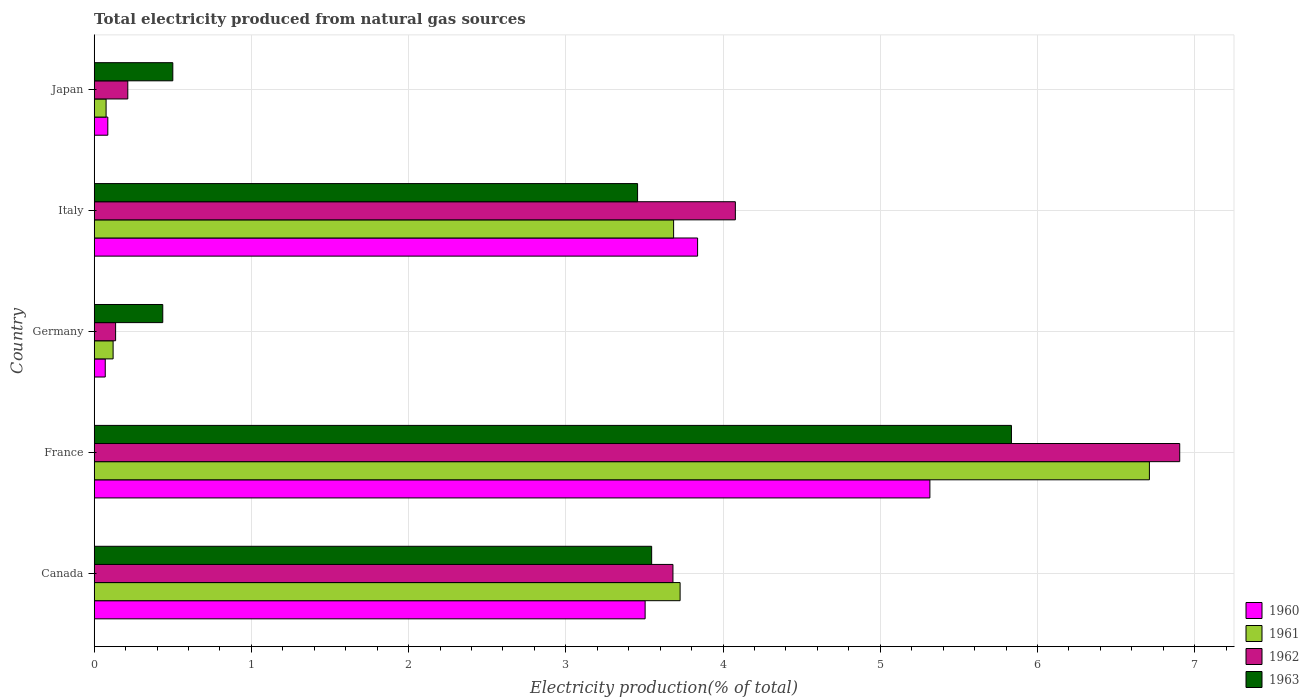Are the number of bars per tick equal to the number of legend labels?
Provide a succinct answer. Yes. How many bars are there on the 5th tick from the top?
Offer a very short reply. 4. How many bars are there on the 3rd tick from the bottom?
Give a very brief answer. 4. What is the label of the 1st group of bars from the top?
Provide a short and direct response. Japan. In how many cases, is the number of bars for a given country not equal to the number of legend labels?
Your answer should be very brief. 0. What is the total electricity produced in 1963 in Germany?
Give a very brief answer. 0.44. Across all countries, what is the maximum total electricity produced in 1961?
Ensure brevity in your answer.  6.71. Across all countries, what is the minimum total electricity produced in 1961?
Make the answer very short. 0.08. What is the total total electricity produced in 1961 in the graph?
Give a very brief answer. 14.32. What is the difference between the total electricity produced in 1961 in Canada and that in Japan?
Your response must be concise. 3.65. What is the difference between the total electricity produced in 1960 in Italy and the total electricity produced in 1963 in Canada?
Give a very brief answer. 0.29. What is the average total electricity produced in 1961 per country?
Ensure brevity in your answer.  2.86. What is the difference between the total electricity produced in 1960 and total electricity produced in 1961 in Germany?
Ensure brevity in your answer.  -0.05. What is the ratio of the total electricity produced in 1963 in Canada to that in Germany?
Ensure brevity in your answer.  8.13. Is the total electricity produced in 1961 in Italy less than that in Japan?
Offer a terse response. No. What is the difference between the highest and the second highest total electricity produced in 1962?
Offer a very short reply. 2.83. What is the difference between the highest and the lowest total electricity produced in 1961?
Your response must be concise. 6.64. Is the sum of the total electricity produced in 1960 in Canada and Germany greater than the maximum total electricity produced in 1961 across all countries?
Ensure brevity in your answer.  No. What does the 3rd bar from the bottom in Italy represents?
Give a very brief answer. 1962. What is the difference between two consecutive major ticks on the X-axis?
Provide a succinct answer. 1. Are the values on the major ticks of X-axis written in scientific E-notation?
Give a very brief answer. No. Where does the legend appear in the graph?
Make the answer very short. Bottom right. What is the title of the graph?
Ensure brevity in your answer.  Total electricity produced from natural gas sources. Does "1960" appear as one of the legend labels in the graph?
Your response must be concise. Yes. What is the Electricity production(% of total) of 1960 in Canada?
Offer a very short reply. 3.5. What is the Electricity production(% of total) in 1961 in Canada?
Your answer should be very brief. 3.73. What is the Electricity production(% of total) in 1962 in Canada?
Offer a terse response. 3.68. What is the Electricity production(% of total) in 1963 in Canada?
Ensure brevity in your answer.  3.55. What is the Electricity production(% of total) in 1960 in France?
Offer a terse response. 5.32. What is the Electricity production(% of total) in 1961 in France?
Make the answer very short. 6.71. What is the Electricity production(% of total) in 1962 in France?
Offer a very short reply. 6.91. What is the Electricity production(% of total) in 1963 in France?
Your answer should be compact. 5.83. What is the Electricity production(% of total) in 1960 in Germany?
Your response must be concise. 0.07. What is the Electricity production(% of total) of 1961 in Germany?
Your answer should be very brief. 0.12. What is the Electricity production(% of total) in 1962 in Germany?
Keep it short and to the point. 0.14. What is the Electricity production(% of total) of 1963 in Germany?
Provide a short and direct response. 0.44. What is the Electricity production(% of total) of 1960 in Italy?
Your answer should be compact. 3.84. What is the Electricity production(% of total) of 1961 in Italy?
Keep it short and to the point. 3.69. What is the Electricity production(% of total) in 1962 in Italy?
Make the answer very short. 4.08. What is the Electricity production(% of total) in 1963 in Italy?
Make the answer very short. 3.46. What is the Electricity production(% of total) in 1960 in Japan?
Provide a short and direct response. 0.09. What is the Electricity production(% of total) of 1961 in Japan?
Offer a terse response. 0.08. What is the Electricity production(% of total) in 1962 in Japan?
Keep it short and to the point. 0.21. What is the Electricity production(% of total) of 1963 in Japan?
Keep it short and to the point. 0.5. Across all countries, what is the maximum Electricity production(% of total) of 1960?
Make the answer very short. 5.32. Across all countries, what is the maximum Electricity production(% of total) of 1961?
Provide a short and direct response. 6.71. Across all countries, what is the maximum Electricity production(% of total) of 1962?
Offer a terse response. 6.91. Across all countries, what is the maximum Electricity production(% of total) in 1963?
Make the answer very short. 5.83. Across all countries, what is the minimum Electricity production(% of total) in 1960?
Make the answer very short. 0.07. Across all countries, what is the minimum Electricity production(% of total) of 1961?
Provide a succinct answer. 0.08. Across all countries, what is the minimum Electricity production(% of total) of 1962?
Keep it short and to the point. 0.14. Across all countries, what is the minimum Electricity production(% of total) in 1963?
Offer a terse response. 0.44. What is the total Electricity production(% of total) of 1960 in the graph?
Ensure brevity in your answer.  12.82. What is the total Electricity production(% of total) of 1961 in the graph?
Your answer should be compact. 14.32. What is the total Electricity production(% of total) in 1962 in the graph?
Provide a short and direct response. 15.01. What is the total Electricity production(% of total) in 1963 in the graph?
Make the answer very short. 13.77. What is the difference between the Electricity production(% of total) in 1960 in Canada and that in France?
Give a very brief answer. -1.81. What is the difference between the Electricity production(% of total) of 1961 in Canada and that in France?
Give a very brief answer. -2.99. What is the difference between the Electricity production(% of total) of 1962 in Canada and that in France?
Your answer should be compact. -3.22. What is the difference between the Electricity production(% of total) in 1963 in Canada and that in France?
Make the answer very short. -2.29. What is the difference between the Electricity production(% of total) in 1960 in Canada and that in Germany?
Your answer should be compact. 3.43. What is the difference between the Electricity production(% of total) of 1961 in Canada and that in Germany?
Offer a terse response. 3.61. What is the difference between the Electricity production(% of total) in 1962 in Canada and that in Germany?
Your answer should be very brief. 3.55. What is the difference between the Electricity production(% of total) in 1963 in Canada and that in Germany?
Give a very brief answer. 3.11. What is the difference between the Electricity production(% of total) in 1960 in Canada and that in Italy?
Keep it short and to the point. -0.33. What is the difference between the Electricity production(% of total) of 1961 in Canada and that in Italy?
Your response must be concise. 0.04. What is the difference between the Electricity production(% of total) in 1962 in Canada and that in Italy?
Provide a succinct answer. -0.4. What is the difference between the Electricity production(% of total) in 1963 in Canada and that in Italy?
Keep it short and to the point. 0.09. What is the difference between the Electricity production(% of total) of 1960 in Canada and that in Japan?
Keep it short and to the point. 3.42. What is the difference between the Electricity production(% of total) of 1961 in Canada and that in Japan?
Offer a very short reply. 3.65. What is the difference between the Electricity production(% of total) in 1962 in Canada and that in Japan?
Provide a short and direct response. 3.47. What is the difference between the Electricity production(% of total) of 1963 in Canada and that in Japan?
Provide a succinct answer. 3.05. What is the difference between the Electricity production(% of total) of 1960 in France and that in Germany?
Offer a terse response. 5.25. What is the difference between the Electricity production(% of total) in 1961 in France and that in Germany?
Make the answer very short. 6.59. What is the difference between the Electricity production(% of total) of 1962 in France and that in Germany?
Offer a very short reply. 6.77. What is the difference between the Electricity production(% of total) in 1963 in France and that in Germany?
Offer a very short reply. 5.4. What is the difference between the Electricity production(% of total) of 1960 in France and that in Italy?
Make the answer very short. 1.48. What is the difference between the Electricity production(% of total) of 1961 in France and that in Italy?
Keep it short and to the point. 3.03. What is the difference between the Electricity production(% of total) in 1962 in France and that in Italy?
Your response must be concise. 2.83. What is the difference between the Electricity production(% of total) of 1963 in France and that in Italy?
Your answer should be compact. 2.38. What is the difference between the Electricity production(% of total) in 1960 in France and that in Japan?
Ensure brevity in your answer.  5.23. What is the difference between the Electricity production(% of total) of 1961 in France and that in Japan?
Offer a very short reply. 6.64. What is the difference between the Electricity production(% of total) in 1962 in France and that in Japan?
Give a very brief answer. 6.69. What is the difference between the Electricity production(% of total) in 1963 in France and that in Japan?
Your answer should be compact. 5.33. What is the difference between the Electricity production(% of total) of 1960 in Germany and that in Italy?
Offer a terse response. -3.77. What is the difference between the Electricity production(% of total) in 1961 in Germany and that in Italy?
Provide a short and direct response. -3.57. What is the difference between the Electricity production(% of total) in 1962 in Germany and that in Italy?
Keep it short and to the point. -3.94. What is the difference between the Electricity production(% of total) of 1963 in Germany and that in Italy?
Provide a succinct answer. -3.02. What is the difference between the Electricity production(% of total) in 1960 in Germany and that in Japan?
Make the answer very short. -0.02. What is the difference between the Electricity production(% of total) in 1961 in Germany and that in Japan?
Ensure brevity in your answer.  0.04. What is the difference between the Electricity production(% of total) of 1962 in Germany and that in Japan?
Keep it short and to the point. -0.08. What is the difference between the Electricity production(% of total) of 1963 in Germany and that in Japan?
Give a very brief answer. -0.06. What is the difference between the Electricity production(% of total) of 1960 in Italy and that in Japan?
Offer a very short reply. 3.75. What is the difference between the Electricity production(% of total) of 1961 in Italy and that in Japan?
Provide a succinct answer. 3.61. What is the difference between the Electricity production(% of total) of 1962 in Italy and that in Japan?
Make the answer very short. 3.86. What is the difference between the Electricity production(% of total) in 1963 in Italy and that in Japan?
Provide a succinct answer. 2.96. What is the difference between the Electricity production(% of total) in 1960 in Canada and the Electricity production(% of total) in 1961 in France?
Offer a very short reply. -3.21. What is the difference between the Electricity production(% of total) of 1960 in Canada and the Electricity production(% of total) of 1962 in France?
Your answer should be compact. -3.4. What is the difference between the Electricity production(% of total) in 1960 in Canada and the Electricity production(% of total) in 1963 in France?
Provide a short and direct response. -2.33. What is the difference between the Electricity production(% of total) of 1961 in Canada and the Electricity production(% of total) of 1962 in France?
Your answer should be very brief. -3.18. What is the difference between the Electricity production(% of total) of 1961 in Canada and the Electricity production(% of total) of 1963 in France?
Your response must be concise. -2.11. What is the difference between the Electricity production(% of total) of 1962 in Canada and the Electricity production(% of total) of 1963 in France?
Your answer should be compact. -2.15. What is the difference between the Electricity production(% of total) in 1960 in Canada and the Electricity production(% of total) in 1961 in Germany?
Give a very brief answer. 3.38. What is the difference between the Electricity production(% of total) of 1960 in Canada and the Electricity production(% of total) of 1962 in Germany?
Provide a succinct answer. 3.37. What is the difference between the Electricity production(% of total) of 1960 in Canada and the Electricity production(% of total) of 1963 in Germany?
Provide a succinct answer. 3.07. What is the difference between the Electricity production(% of total) in 1961 in Canada and the Electricity production(% of total) in 1962 in Germany?
Your answer should be very brief. 3.59. What is the difference between the Electricity production(% of total) in 1961 in Canada and the Electricity production(% of total) in 1963 in Germany?
Provide a short and direct response. 3.29. What is the difference between the Electricity production(% of total) of 1962 in Canada and the Electricity production(% of total) of 1963 in Germany?
Keep it short and to the point. 3.25. What is the difference between the Electricity production(% of total) in 1960 in Canada and the Electricity production(% of total) in 1961 in Italy?
Make the answer very short. -0.18. What is the difference between the Electricity production(% of total) of 1960 in Canada and the Electricity production(% of total) of 1962 in Italy?
Offer a very short reply. -0.57. What is the difference between the Electricity production(% of total) of 1960 in Canada and the Electricity production(% of total) of 1963 in Italy?
Ensure brevity in your answer.  0.05. What is the difference between the Electricity production(% of total) in 1961 in Canada and the Electricity production(% of total) in 1962 in Italy?
Provide a short and direct response. -0.35. What is the difference between the Electricity production(% of total) of 1961 in Canada and the Electricity production(% of total) of 1963 in Italy?
Give a very brief answer. 0.27. What is the difference between the Electricity production(% of total) of 1962 in Canada and the Electricity production(% of total) of 1963 in Italy?
Make the answer very short. 0.23. What is the difference between the Electricity production(% of total) of 1960 in Canada and the Electricity production(% of total) of 1961 in Japan?
Keep it short and to the point. 3.43. What is the difference between the Electricity production(% of total) in 1960 in Canada and the Electricity production(% of total) in 1962 in Japan?
Offer a terse response. 3.29. What is the difference between the Electricity production(% of total) of 1960 in Canada and the Electricity production(% of total) of 1963 in Japan?
Your response must be concise. 3. What is the difference between the Electricity production(% of total) in 1961 in Canada and the Electricity production(% of total) in 1962 in Japan?
Offer a very short reply. 3.51. What is the difference between the Electricity production(% of total) of 1961 in Canada and the Electricity production(% of total) of 1963 in Japan?
Make the answer very short. 3.23. What is the difference between the Electricity production(% of total) of 1962 in Canada and the Electricity production(% of total) of 1963 in Japan?
Your response must be concise. 3.18. What is the difference between the Electricity production(% of total) in 1960 in France and the Electricity production(% of total) in 1961 in Germany?
Your answer should be compact. 5.2. What is the difference between the Electricity production(% of total) of 1960 in France and the Electricity production(% of total) of 1962 in Germany?
Your response must be concise. 5.18. What is the difference between the Electricity production(% of total) in 1960 in France and the Electricity production(% of total) in 1963 in Germany?
Your answer should be very brief. 4.88. What is the difference between the Electricity production(% of total) in 1961 in France and the Electricity production(% of total) in 1962 in Germany?
Offer a very short reply. 6.58. What is the difference between the Electricity production(% of total) of 1961 in France and the Electricity production(% of total) of 1963 in Germany?
Keep it short and to the point. 6.28. What is the difference between the Electricity production(% of total) of 1962 in France and the Electricity production(% of total) of 1963 in Germany?
Keep it short and to the point. 6.47. What is the difference between the Electricity production(% of total) of 1960 in France and the Electricity production(% of total) of 1961 in Italy?
Provide a succinct answer. 1.63. What is the difference between the Electricity production(% of total) in 1960 in France and the Electricity production(% of total) in 1962 in Italy?
Provide a short and direct response. 1.24. What is the difference between the Electricity production(% of total) in 1960 in France and the Electricity production(% of total) in 1963 in Italy?
Ensure brevity in your answer.  1.86. What is the difference between the Electricity production(% of total) of 1961 in France and the Electricity production(% of total) of 1962 in Italy?
Offer a very short reply. 2.63. What is the difference between the Electricity production(% of total) in 1961 in France and the Electricity production(% of total) in 1963 in Italy?
Give a very brief answer. 3.26. What is the difference between the Electricity production(% of total) in 1962 in France and the Electricity production(% of total) in 1963 in Italy?
Ensure brevity in your answer.  3.45. What is the difference between the Electricity production(% of total) of 1960 in France and the Electricity production(% of total) of 1961 in Japan?
Keep it short and to the point. 5.24. What is the difference between the Electricity production(% of total) in 1960 in France and the Electricity production(% of total) in 1962 in Japan?
Offer a terse response. 5.1. What is the difference between the Electricity production(% of total) of 1960 in France and the Electricity production(% of total) of 1963 in Japan?
Your answer should be compact. 4.82. What is the difference between the Electricity production(% of total) in 1961 in France and the Electricity production(% of total) in 1962 in Japan?
Provide a succinct answer. 6.5. What is the difference between the Electricity production(% of total) in 1961 in France and the Electricity production(% of total) in 1963 in Japan?
Your answer should be compact. 6.21. What is the difference between the Electricity production(% of total) in 1962 in France and the Electricity production(% of total) in 1963 in Japan?
Make the answer very short. 6.4. What is the difference between the Electricity production(% of total) of 1960 in Germany and the Electricity production(% of total) of 1961 in Italy?
Offer a very short reply. -3.62. What is the difference between the Electricity production(% of total) of 1960 in Germany and the Electricity production(% of total) of 1962 in Italy?
Offer a very short reply. -4.01. What is the difference between the Electricity production(% of total) in 1960 in Germany and the Electricity production(% of total) in 1963 in Italy?
Give a very brief answer. -3.39. What is the difference between the Electricity production(% of total) of 1961 in Germany and the Electricity production(% of total) of 1962 in Italy?
Your response must be concise. -3.96. What is the difference between the Electricity production(% of total) in 1961 in Germany and the Electricity production(% of total) in 1963 in Italy?
Keep it short and to the point. -3.34. What is the difference between the Electricity production(% of total) of 1962 in Germany and the Electricity production(% of total) of 1963 in Italy?
Ensure brevity in your answer.  -3.32. What is the difference between the Electricity production(% of total) of 1960 in Germany and the Electricity production(% of total) of 1961 in Japan?
Keep it short and to the point. -0.01. What is the difference between the Electricity production(% of total) in 1960 in Germany and the Electricity production(% of total) in 1962 in Japan?
Offer a very short reply. -0.14. What is the difference between the Electricity production(% of total) of 1960 in Germany and the Electricity production(% of total) of 1963 in Japan?
Your answer should be very brief. -0.43. What is the difference between the Electricity production(% of total) of 1961 in Germany and the Electricity production(% of total) of 1962 in Japan?
Provide a succinct answer. -0.09. What is the difference between the Electricity production(% of total) in 1961 in Germany and the Electricity production(% of total) in 1963 in Japan?
Your response must be concise. -0.38. What is the difference between the Electricity production(% of total) of 1962 in Germany and the Electricity production(% of total) of 1963 in Japan?
Your response must be concise. -0.36. What is the difference between the Electricity production(% of total) in 1960 in Italy and the Electricity production(% of total) in 1961 in Japan?
Offer a terse response. 3.76. What is the difference between the Electricity production(% of total) of 1960 in Italy and the Electricity production(% of total) of 1962 in Japan?
Offer a very short reply. 3.62. What is the difference between the Electricity production(% of total) in 1960 in Italy and the Electricity production(% of total) in 1963 in Japan?
Make the answer very short. 3.34. What is the difference between the Electricity production(% of total) of 1961 in Italy and the Electricity production(% of total) of 1962 in Japan?
Your answer should be very brief. 3.47. What is the difference between the Electricity production(% of total) of 1961 in Italy and the Electricity production(% of total) of 1963 in Japan?
Offer a very short reply. 3.19. What is the difference between the Electricity production(% of total) of 1962 in Italy and the Electricity production(% of total) of 1963 in Japan?
Make the answer very short. 3.58. What is the average Electricity production(% of total) of 1960 per country?
Your answer should be compact. 2.56. What is the average Electricity production(% of total) in 1961 per country?
Give a very brief answer. 2.86. What is the average Electricity production(% of total) in 1962 per country?
Provide a short and direct response. 3. What is the average Electricity production(% of total) in 1963 per country?
Your response must be concise. 2.75. What is the difference between the Electricity production(% of total) of 1960 and Electricity production(% of total) of 1961 in Canada?
Ensure brevity in your answer.  -0.22. What is the difference between the Electricity production(% of total) in 1960 and Electricity production(% of total) in 1962 in Canada?
Keep it short and to the point. -0.18. What is the difference between the Electricity production(% of total) in 1960 and Electricity production(% of total) in 1963 in Canada?
Provide a short and direct response. -0.04. What is the difference between the Electricity production(% of total) in 1961 and Electricity production(% of total) in 1962 in Canada?
Keep it short and to the point. 0.05. What is the difference between the Electricity production(% of total) in 1961 and Electricity production(% of total) in 1963 in Canada?
Ensure brevity in your answer.  0.18. What is the difference between the Electricity production(% of total) in 1962 and Electricity production(% of total) in 1963 in Canada?
Provide a short and direct response. 0.14. What is the difference between the Electricity production(% of total) of 1960 and Electricity production(% of total) of 1961 in France?
Provide a short and direct response. -1.4. What is the difference between the Electricity production(% of total) in 1960 and Electricity production(% of total) in 1962 in France?
Offer a very short reply. -1.59. What is the difference between the Electricity production(% of total) of 1960 and Electricity production(% of total) of 1963 in France?
Provide a short and direct response. -0.52. What is the difference between the Electricity production(% of total) of 1961 and Electricity production(% of total) of 1962 in France?
Make the answer very short. -0.19. What is the difference between the Electricity production(% of total) in 1961 and Electricity production(% of total) in 1963 in France?
Your response must be concise. 0.88. What is the difference between the Electricity production(% of total) of 1962 and Electricity production(% of total) of 1963 in France?
Your answer should be very brief. 1.07. What is the difference between the Electricity production(% of total) of 1960 and Electricity production(% of total) of 1962 in Germany?
Your answer should be compact. -0.07. What is the difference between the Electricity production(% of total) of 1960 and Electricity production(% of total) of 1963 in Germany?
Give a very brief answer. -0.37. What is the difference between the Electricity production(% of total) in 1961 and Electricity production(% of total) in 1962 in Germany?
Your response must be concise. -0.02. What is the difference between the Electricity production(% of total) in 1961 and Electricity production(% of total) in 1963 in Germany?
Keep it short and to the point. -0.32. What is the difference between the Electricity production(% of total) in 1962 and Electricity production(% of total) in 1963 in Germany?
Make the answer very short. -0.3. What is the difference between the Electricity production(% of total) in 1960 and Electricity production(% of total) in 1961 in Italy?
Your response must be concise. 0.15. What is the difference between the Electricity production(% of total) in 1960 and Electricity production(% of total) in 1962 in Italy?
Make the answer very short. -0.24. What is the difference between the Electricity production(% of total) in 1960 and Electricity production(% of total) in 1963 in Italy?
Provide a short and direct response. 0.38. What is the difference between the Electricity production(% of total) of 1961 and Electricity production(% of total) of 1962 in Italy?
Your response must be concise. -0.39. What is the difference between the Electricity production(% of total) in 1961 and Electricity production(% of total) in 1963 in Italy?
Your answer should be very brief. 0.23. What is the difference between the Electricity production(% of total) in 1962 and Electricity production(% of total) in 1963 in Italy?
Your answer should be compact. 0.62. What is the difference between the Electricity production(% of total) of 1960 and Electricity production(% of total) of 1961 in Japan?
Provide a short and direct response. 0.01. What is the difference between the Electricity production(% of total) in 1960 and Electricity production(% of total) in 1962 in Japan?
Make the answer very short. -0.13. What is the difference between the Electricity production(% of total) in 1960 and Electricity production(% of total) in 1963 in Japan?
Offer a very short reply. -0.41. What is the difference between the Electricity production(% of total) of 1961 and Electricity production(% of total) of 1962 in Japan?
Offer a terse response. -0.14. What is the difference between the Electricity production(% of total) of 1961 and Electricity production(% of total) of 1963 in Japan?
Provide a succinct answer. -0.42. What is the difference between the Electricity production(% of total) in 1962 and Electricity production(% of total) in 1963 in Japan?
Your response must be concise. -0.29. What is the ratio of the Electricity production(% of total) of 1960 in Canada to that in France?
Your answer should be very brief. 0.66. What is the ratio of the Electricity production(% of total) in 1961 in Canada to that in France?
Your response must be concise. 0.56. What is the ratio of the Electricity production(% of total) in 1962 in Canada to that in France?
Your answer should be compact. 0.53. What is the ratio of the Electricity production(% of total) in 1963 in Canada to that in France?
Offer a very short reply. 0.61. What is the ratio of the Electricity production(% of total) in 1960 in Canada to that in Germany?
Offer a very short reply. 49.85. What is the ratio of the Electricity production(% of total) of 1961 in Canada to that in Germany?
Your answer should be compact. 30.98. What is the ratio of the Electricity production(% of total) in 1962 in Canada to that in Germany?
Give a very brief answer. 27.02. What is the ratio of the Electricity production(% of total) of 1963 in Canada to that in Germany?
Provide a succinct answer. 8.13. What is the ratio of the Electricity production(% of total) of 1960 in Canada to that in Italy?
Give a very brief answer. 0.91. What is the ratio of the Electricity production(% of total) in 1961 in Canada to that in Italy?
Ensure brevity in your answer.  1.01. What is the ratio of the Electricity production(% of total) of 1962 in Canada to that in Italy?
Give a very brief answer. 0.9. What is the ratio of the Electricity production(% of total) in 1963 in Canada to that in Italy?
Offer a terse response. 1.03. What is the ratio of the Electricity production(% of total) of 1960 in Canada to that in Japan?
Offer a terse response. 40.48. What is the ratio of the Electricity production(% of total) in 1961 in Canada to that in Japan?
Your response must be concise. 49.23. What is the ratio of the Electricity production(% of total) in 1962 in Canada to that in Japan?
Give a very brief answer. 17.23. What is the ratio of the Electricity production(% of total) of 1963 in Canada to that in Japan?
Your answer should be compact. 7.09. What is the ratio of the Electricity production(% of total) in 1960 in France to that in Germany?
Provide a succinct answer. 75.62. What is the ratio of the Electricity production(% of total) in 1961 in France to that in Germany?
Provide a succinct answer. 55.79. What is the ratio of the Electricity production(% of total) of 1962 in France to that in Germany?
Your response must be concise. 50.69. What is the ratio of the Electricity production(% of total) in 1963 in France to that in Germany?
Your response must be concise. 13.38. What is the ratio of the Electricity production(% of total) in 1960 in France to that in Italy?
Keep it short and to the point. 1.39. What is the ratio of the Electricity production(% of total) in 1961 in France to that in Italy?
Provide a succinct answer. 1.82. What is the ratio of the Electricity production(% of total) in 1962 in France to that in Italy?
Offer a very short reply. 1.69. What is the ratio of the Electricity production(% of total) of 1963 in France to that in Italy?
Your answer should be very brief. 1.69. What is the ratio of the Electricity production(% of total) of 1960 in France to that in Japan?
Your answer should be very brief. 61.4. What is the ratio of the Electricity production(% of total) of 1961 in France to that in Japan?
Your answer should be compact. 88.67. What is the ratio of the Electricity production(% of total) of 1962 in France to that in Japan?
Provide a succinct answer. 32.32. What is the ratio of the Electricity production(% of total) in 1963 in France to that in Japan?
Your answer should be very brief. 11.67. What is the ratio of the Electricity production(% of total) in 1960 in Germany to that in Italy?
Provide a short and direct response. 0.02. What is the ratio of the Electricity production(% of total) of 1961 in Germany to that in Italy?
Keep it short and to the point. 0.03. What is the ratio of the Electricity production(% of total) in 1962 in Germany to that in Italy?
Your response must be concise. 0.03. What is the ratio of the Electricity production(% of total) of 1963 in Germany to that in Italy?
Give a very brief answer. 0.13. What is the ratio of the Electricity production(% of total) of 1960 in Germany to that in Japan?
Offer a very short reply. 0.81. What is the ratio of the Electricity production(% of total) in 1961 in Germany to that in Japan?
Keep it short and to the point. 1.59. What is the ratio of the Electricity production(% of total) of 1962 in Germany to that in Japan?
Offer a terse response. 0.64. What is the ratio of the Electricity production(% of total) in 1963 in Germany to that in Japan?
Ensure brevity in your answer.  0.87. What is the ratio of the Electricity production(% of total) of 1960 in Italy to that in Japan?
Provide a succinct answer. 44.33. What is the ratio of the Electricity production(% of total) of 1961 in Italy to that in Japan?
Give a very brief answer. 48.69. What is the ratio of the Electricity production(% of total) in 1962 in Italy to that in Japan?
Provide a short and direct response. 19.09. What is the ratio of the Electricity production(% of total) of 1963 in Italy to that in Japan?
Make the answer very short. 6.91. What is the difference between the highest and the second highest Electricity production(% of total) in 1960?
Give a very brief answer. 1.48. What is the difference between the highest and the second highest Electricity production(% of total) of 1961?
Provide a short and direct response. 2.99. What is the difference between the highest and the second highest Electricity production(% of total) of 1962?
Make the answer very short. 2.83. What is the difference between the highest and the second highest Electricity production(% of total) of 1963?
Offer a very short reply. 2.29. What is the difference between the highest and the lowest Electricity production(% of total) in 1960?
Offer a very short reply. 5.25. What is the difference between the highest and the lowest Electricity production(% of total) of 1961?
Offer a very short reply. 6.64. What is the difference between the highest and the lowest Electricity production(% of total) in 1962?
Ensure brevity in your answer.  6.77. What is the difference between the highest and the lowest Electricity production(% of total) of 1963?
Make the answer very short. 5.4. 